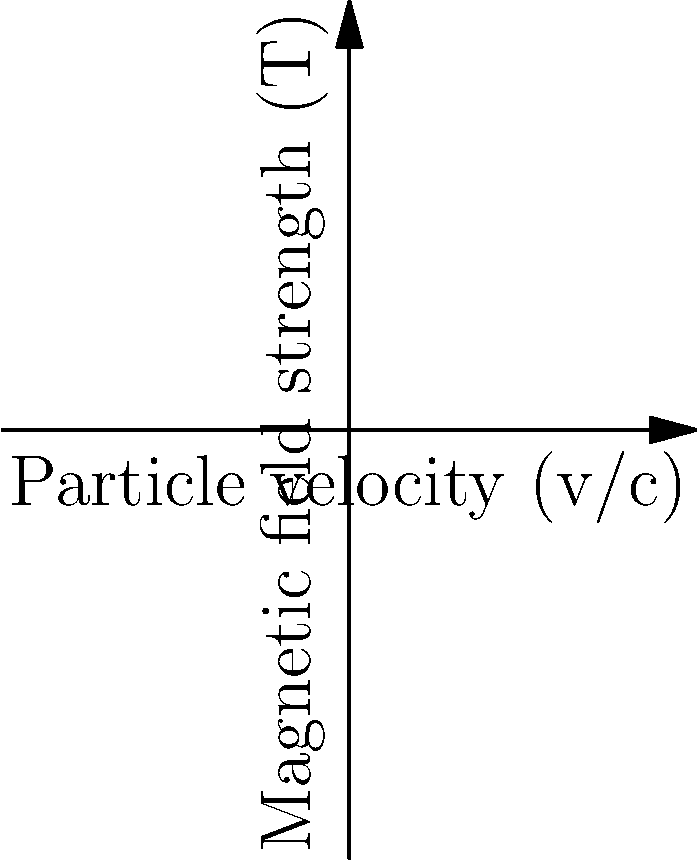The graph shows the relationship between particle velocity (as a fraction of the speed of light) and the required magnetic field strength for circular motion in a particle accelerator. Compare the magnetic field strengths needed for a proton and an alpha particle traveling at half the speed of light. What physical property of these particles primarily accounts for this difference? To answer this question, let's follow these steps:

1. Identify the particles:
   - Blue line represents protons
   - Red line represents alpha particles

2. Find the magnetic field strengths at v = 0.5c:
   - Point A (proton): 0.25 T
   - Point B (alpha particle): 1 T

3. Compare the magnetic field strengths:
   - The alpha particle requires a magnetic field strength 4 times greater than the proton at the same velocity.

4. Recall the equation for the magnetic force on a charged particle:
   $$ F = qvB $$
   where $F$ is the force, $q$ is the charge, $v$ is the velocity, and $B$ is the magnetic field strength.

5. For circular motion, this force provides the centripetal force:
   $$ \frac{mv^2}{r} = qvB $$

6. Rearranging for $B$:
   $$ B = \frac{mv}{qr} $$

7. Compare the properties of protons and alpha particles:
   - Mass: Alpha particle mass ≈ 4 × proton mass
   - Charge: Alpha particle charge = +2e, proton charge = +e

8. The ratio of magnetic field strengths is determined by the ratio of $\frac{m}{q}$:
   $$ \frac{B_{\alpha}}{B_p} = \frac{m_{\alpha}/q_{\alpha}}{m_p/q_p} = \frac{4m_p/(2e)}{m_p/e} = 2 $$

9. This ratio of 2 explains why the alpha particle requires a magnetic field twice as strong for a given velocity. The factor of 4 observed in the graph is due to the quadratic nature of the relationship between B and v.

The primary physical property accounting for this difference is the mass-to-charge ratio of the particles.
Answer: Mass-to-charge ratio 